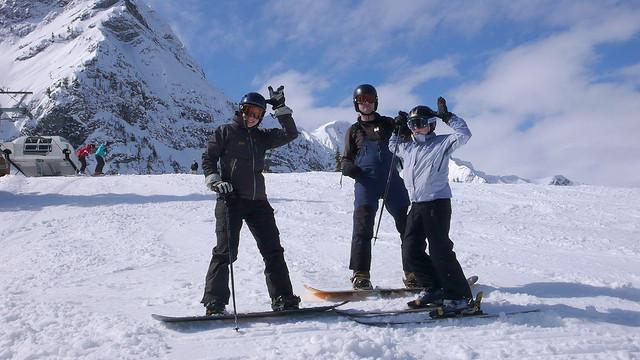How many skis are in this picture?
Answer briefly. 2. What color is his sweatshirt?
Quick response, please. Gray. Who is the shortest person in this picture?
Quick response, please. White jacket. How many people have snowboards?
Answer briefly. 2. Do they look warm?
Concise answer only. Yes. What are the men wearing on their heads?
Be succinct. Helmets. What are they about to do?
Quick response, please. Snowboard. 